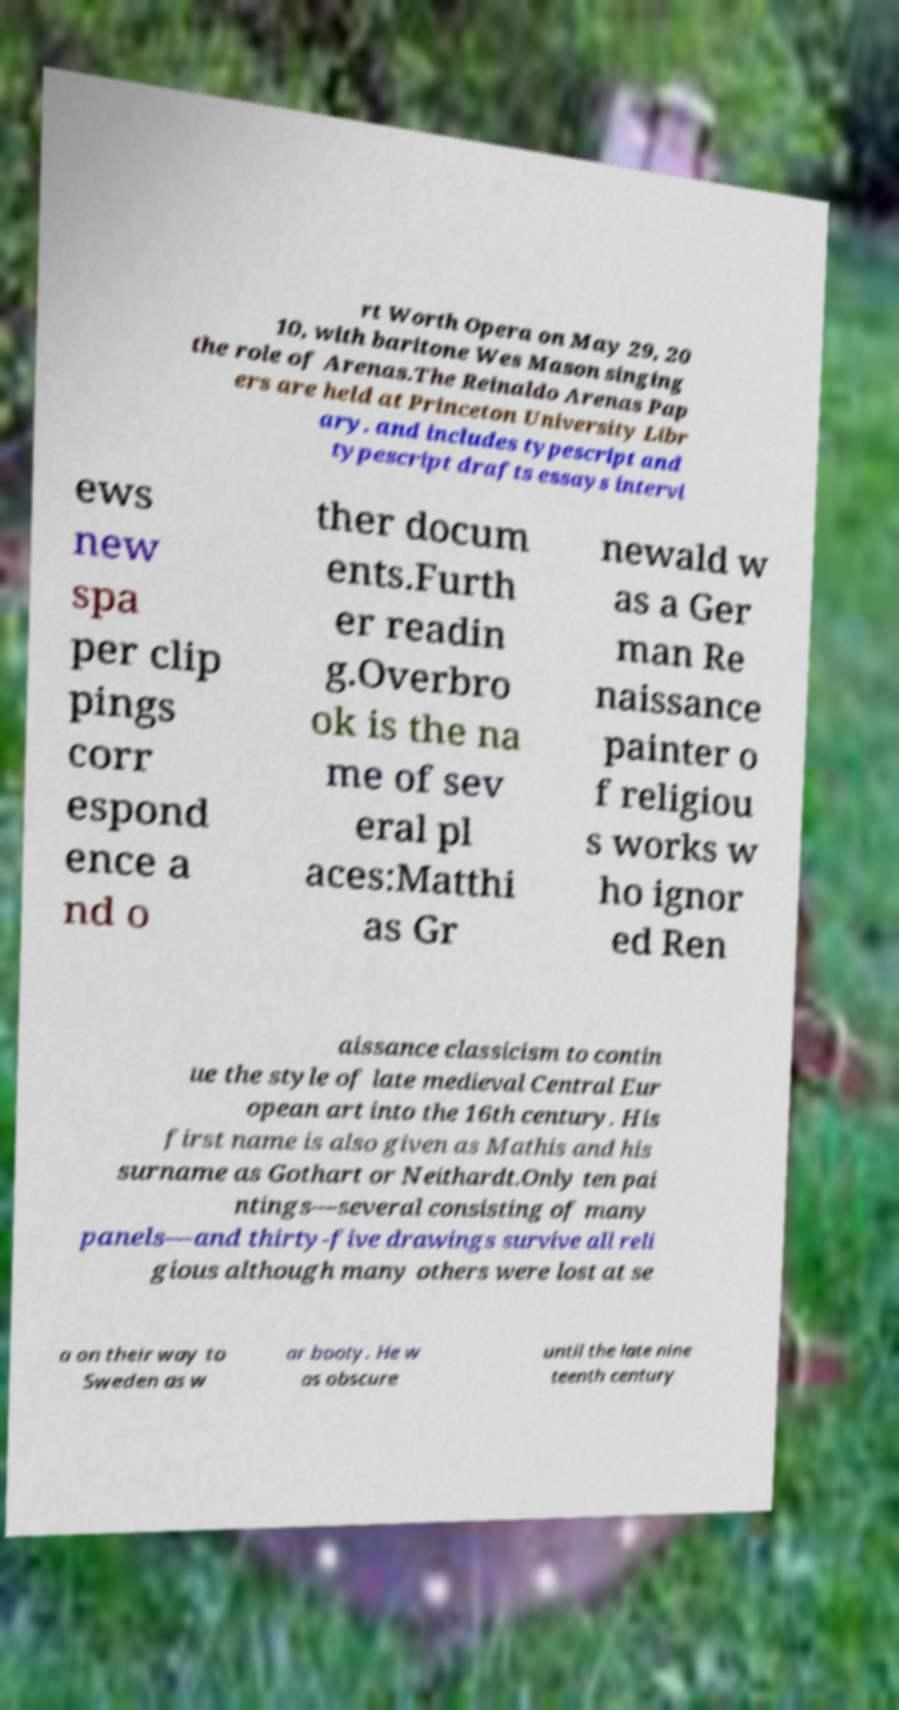What messages or text are displayed in this image? I need them in a readable, typed format. rt Worth Opera on May 29, 20 10, with baritone Wes Mason singing the role of Arenas.The Reinaldo Arenas Pap ers are held at Princeton University Libr ary. and includes typescript and typescript drafts essays intervi ews new spa per clip pings corr espond ence a nd o ther docum ents.Furth er readin g.Overbro ok is the na me of sev eral pl aces:Matthi as Gr newald w as a Ger man Re naissance painter o f religiou s works w ho ignor ed Ren aissance classicism to contin ue the style of late medieval Central Eur opean art into the 16th century. His first name is also given as Mathis and his surname as Gothart or Neithardt.Only ten pai ntings—several consisting of many panels—and thirty-five drawings survive all reli gious although many others were lost at se a on their way to Sweden as w ar booty. He w as obscure until the late nine teenth century 